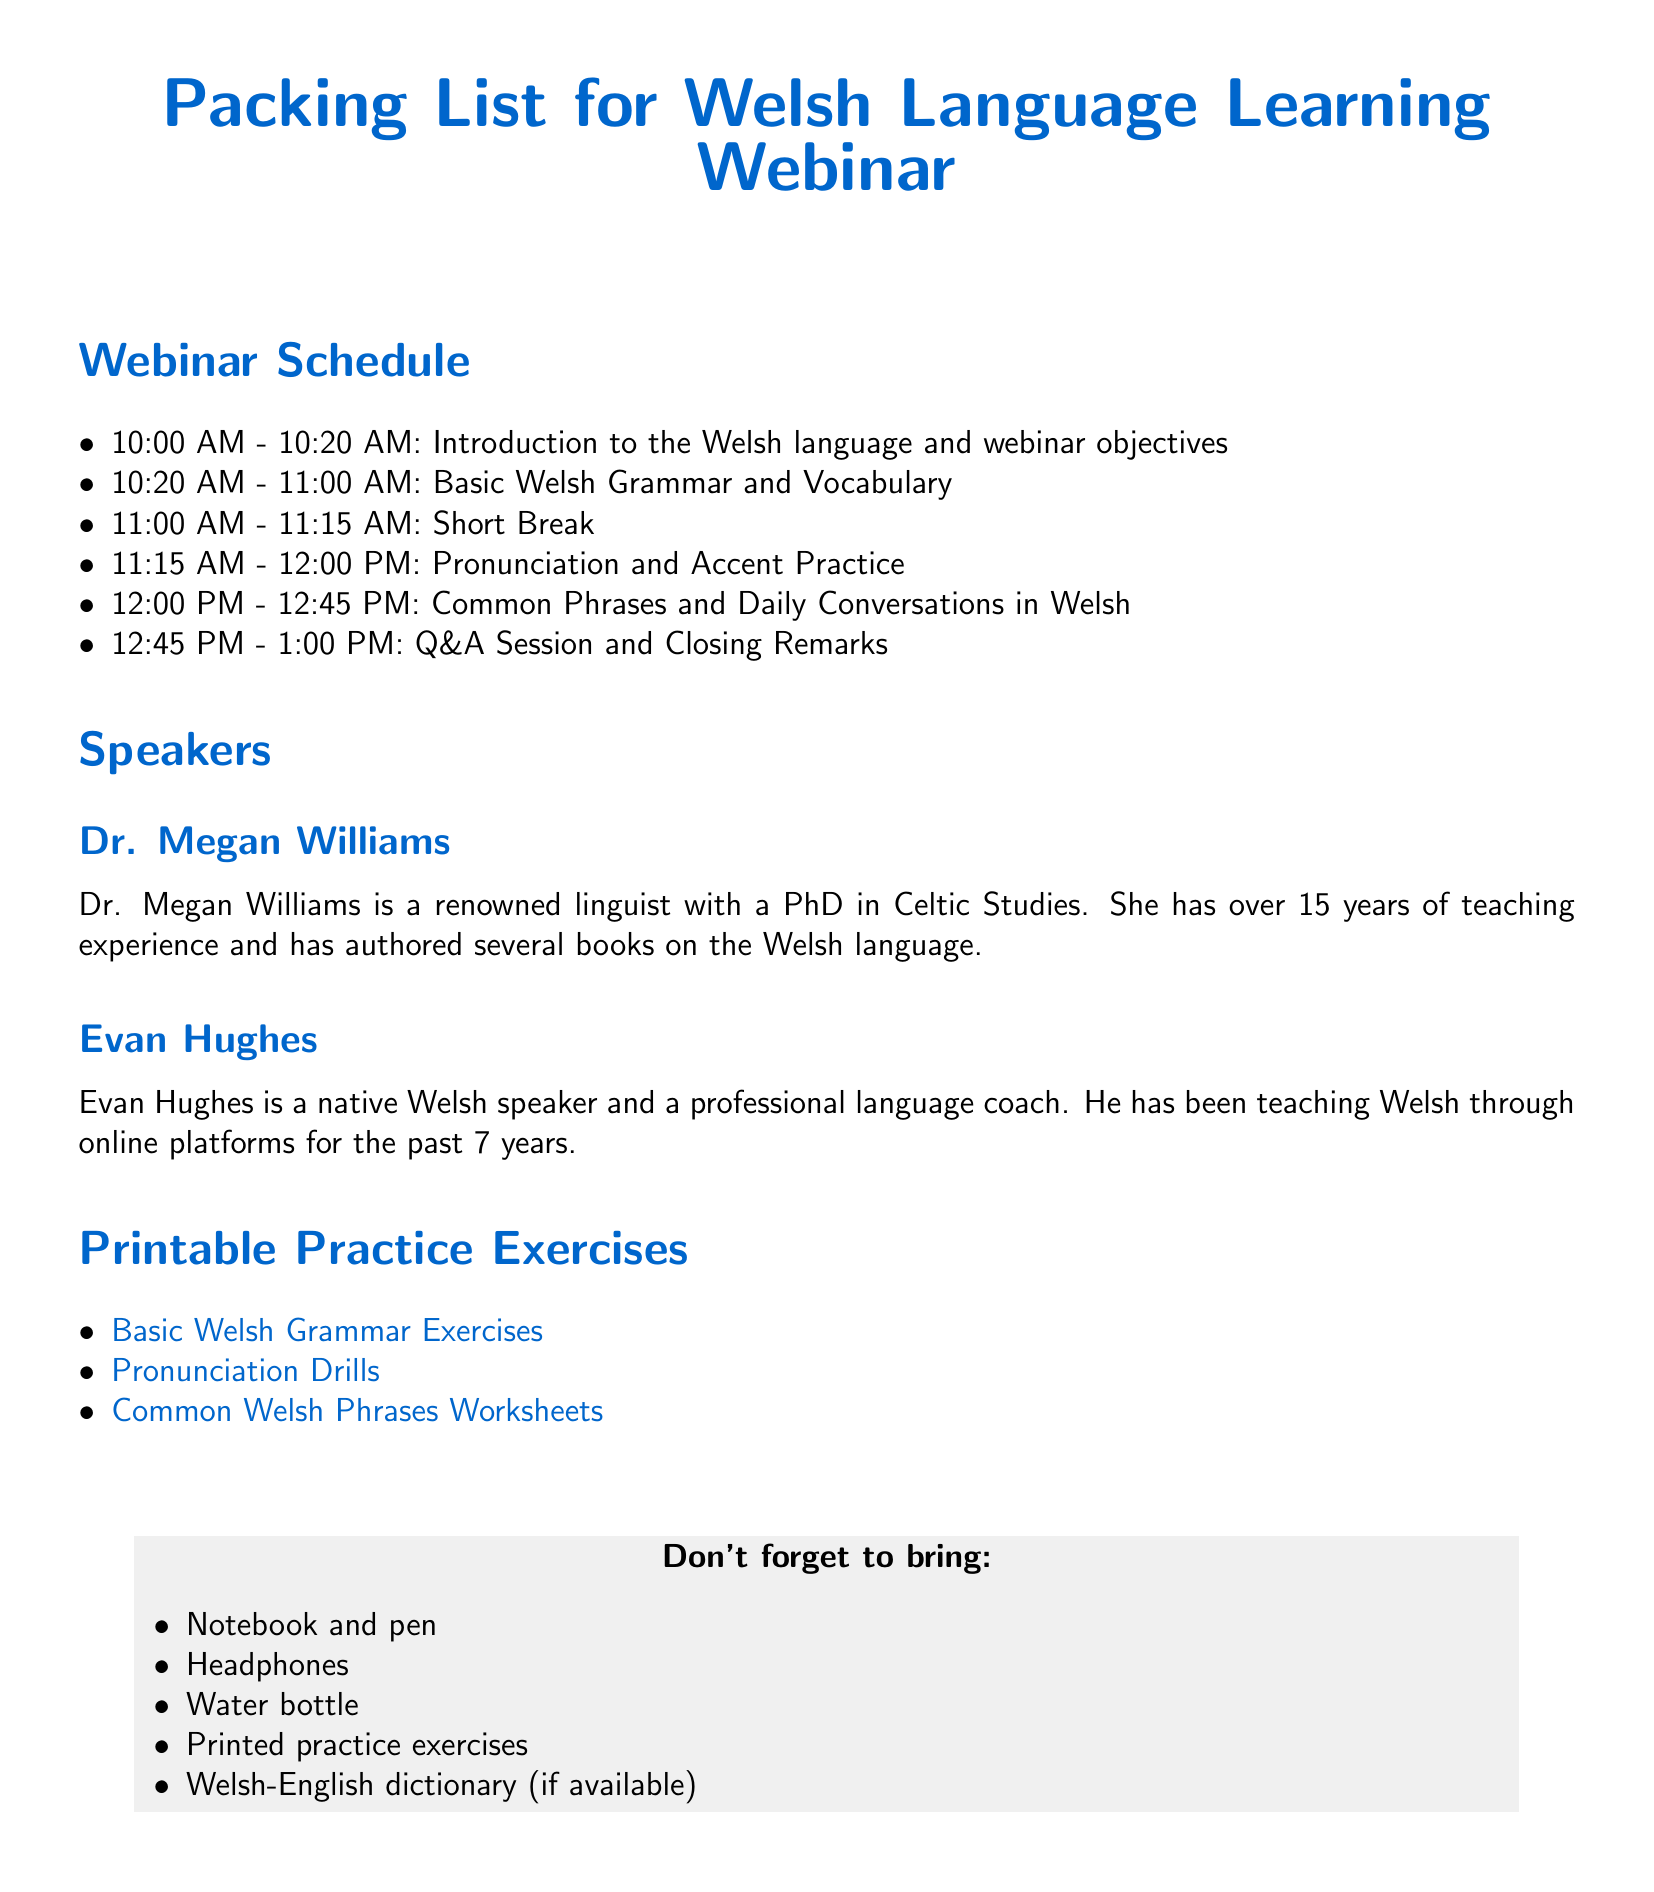What time does the webinar start? The webinar starts at 10:00 AM as noted in the schedule.
Answer: 10:00 AM Who is the first speaker? The first speaker listed is Dr. Megan Williams in the Speakers section.
Answer: Dr. Megan Williams How long is the Q&A session? The Q&A session is scheduled for 15 minutes according to the provided schedule.
Answer: 15 minutes What item is recommended for participants to bring for taking notes? The document specifically mentions to bring a notebook and pen for taking notes.
Answer: Notebook and pen How many speakers are listed in the document? The document mentions two speakers, Dr. Megan Williams and Evan Hughes.
Answer: Two speakers What is the first topic covered in the webinar? The first topic covered is the Introduction to the Welsh language and webinar objectives according to the schedule.
Answer: Introduction to the Welsh language and webinar objectives Which resource is listed for practicing common phrases in Welsh? The document lists a worksheet for common Welsh phrases as a resource.
Answer: Common Welsh Phrases Worksheets What is one of the suggested items to stay hydrated? A water bottle is listed as a suggested item to bring.
Answer: Water bottle 